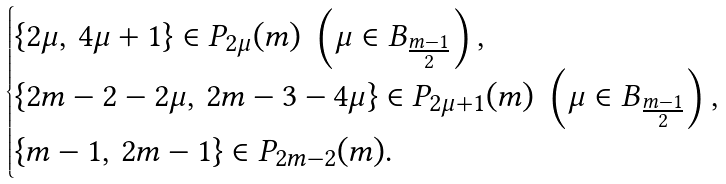<formula> <loc_0><loc_0><loc_500><loc_500>\begin{cases} \{ 2 \mu , \, 4 \mu + 1 \} \in P _ { 2 \mu } ( m ) \ \left ( \mu \in B _ { \frac { m - 1 } { 2 } } \right ) , \\ \{ 2 m - 2 - 2 \mu , \, 2 m - 3 - 4 \mu \} \in P _ { 2 \mu + 1 } ( m ) \ \left ( \mu \in B _ { \frac { m - 1 } { 2 } } \right ) , \\ \{ m - 1 , \, 2 m - 1 \} \in P _ { 2 m - 2 } ( m ) . \end{cases}</formula> 